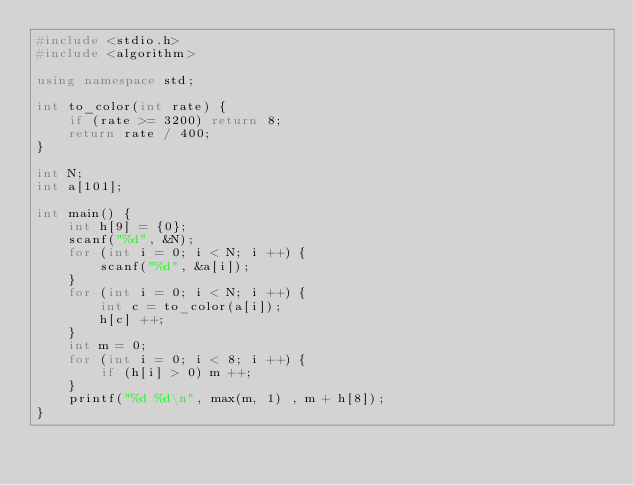Convert code to text. <code><loc_0><loc_0><loc_500><loc_500><_C++_>#include <stdio.h>
#include <algorithm>

using namespace std;

int to_color(int rate) {
    if (rate >= 3200) return 8;
    return rate / 400;
}

int N;
int a[101];

int main() {
    int h[9] = {0};
    scanf("%d", &N);
    for (int i = 0; i < N; i ++) {
        scanf("%d", &a[i]);
    }
    for (int i = 0; i < N; i ++) {
        int c = to_color(a[i]);
        h[c] ++;
    }
    int m = 0;
    for (int i = 0; i < 8; i ++) {
        if (h[i] > 0) m ++;
    }
    printf("%d %d\n", max(m, 1) , m + h[8]);
}</code> 